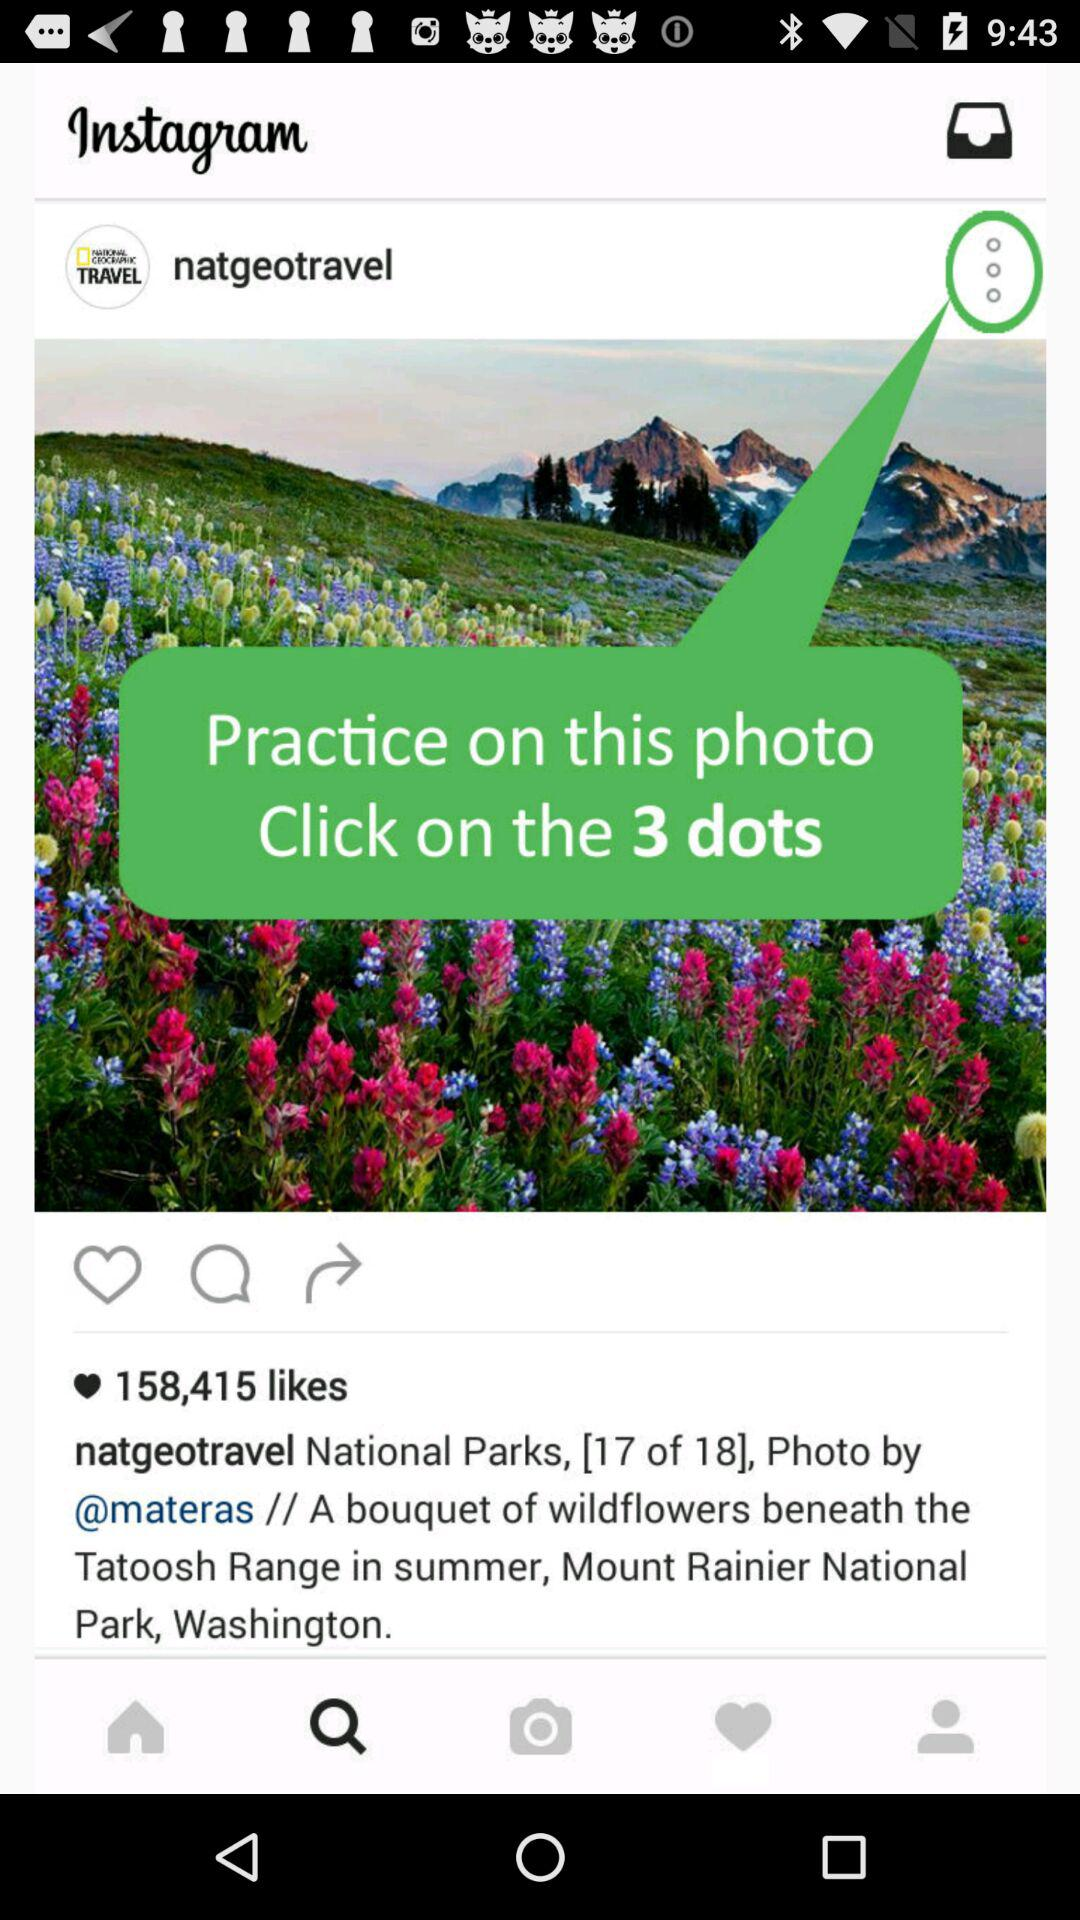How many likes are on the photo?
Answer the question using a single word or phrase. 158,415 